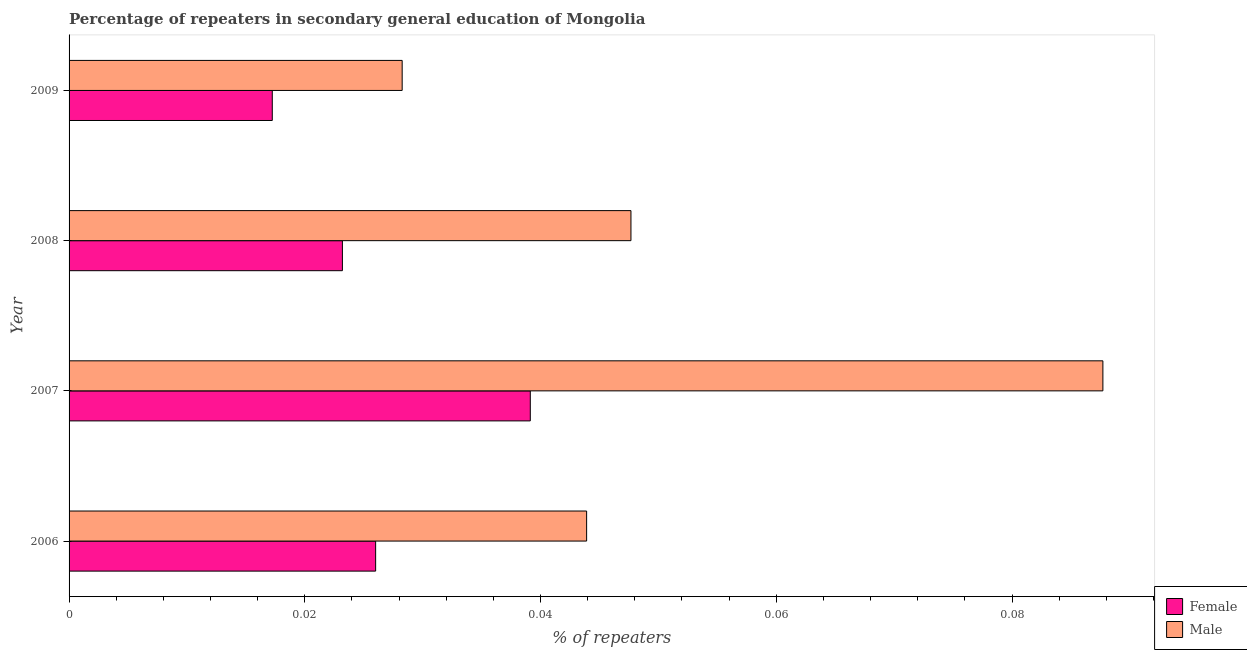How many different coloured bars are there?
Provide a short and direct response. 2. How many groups of bars are there?
Provide a succinct answer. 4. Are the number of bars per tick equal to the number of legend labels?
Offer a very short reply. Yes. Are the number of bars on each tick of the Y-axis equal?
Offer a terse response. Yes. In how many cases, is the number of bars for a given year not equal to the number of legend labels?
Offer a terse response. 0. What is the percentage of female repeaters in 2006?
Give a very brief answer. 0.03. Across all years, what is the maximum percentage of female repeaters?
Your response must be concise. 0.04. Across all years, what is the minimum percentage of female repeaters?
Offer a terse response. 0.02. In which year was the percentage of male repeaters minimum?
Your answer should be very brief. 2009. What is the total percentage of male repeaters in the graph?
Provide a short and direct response. 0.21. What is the difference between the percentage of male repeaters in 2006 and that in 2007?
Ensure brevity in your answer.  -0.04. What is the difference between the percentage of male repeaters in 2006 and the percentage of female repeaters in 2007?
Offer a terse response. 0. What is the average percentage of male repeaters per year?
Give a very brief answer. 0.05. In the year 2009, what is the difference between the percentage of female repeaters and percentage of male repeaters?
Make the answer very short. -0.01. In how many years, is the percentage of male repeaters greater than 0.048 %?
Make the answer very short. 1. What is the ratio of the percentage of female repeaters in 2007 to that in 2008?
Give a very brief answer. 1.69. Is the percentage of female repeaters in 2006 less than that in 2008?
Make the answer very short. No. What is the difference between the highest and the second highest percentage of female repeaters?
Make the answer very short. 0.01. What is the difference between the highest and the lowest percentage of female repeaters?
Provide a short and direct response. 0.02. In how many years, is the percentage of male repeaters greater than the average percentage of male repeaters taken over all years?
Ensure brevity in your answer.  1. What does the 2nd bar from the top in 2009 represents?
Provide a succinct answer. Female. How many bars are there?
Offer a very short reply. 8. Are all the bars in the graph horizontal?
Your answer should be compact. Yes. How many years are there in the graph?
Offer a very short reply. 4. How many legend labels are there?
Provide a short and direct response. 2. How are the legend labels stacked?
Provide a short and direct response. Vertical. What is the title of the graph?
Offer a terse response. Percentage of repeaters in secondary general education of Mongolia. What is the label or title of the X-axis?
Offer a terse response. % of repeaters. What is the label or title of the Y-axis?
Ensure brevity in your answer.  Year. What is the % of repeaters of Female in 2006?
Make the answer very short. 0.03. What is the % of repeaters in Male in 2006?
Your answer should be very brief. 0.04. What is the % of repeaters in Female in 2007?
Provide a short and direct response. 0.04. What is the % of repeaters of Male in 2007?
Make the answer very short. 0.09. What is the % of repeaters of Female in 2008?
Provide a succinct answer. 0.02. What is the % of repeaters in Male in 2008?
Offer a very short reply. 0.05. What is the % of repeaters of Female in 2009?
Provide a short and direct response. 0.02. What is the % of repeaters of Male in 2009?
Offer a terse response. 0.03. Across all years, what is the maximum % of repeaters in Female?
Keep it short and to the point. 0.04. Across all years, what is the maximum % of repeaters of Male?
Give a very brief answer. 0.09. Across all years, what is the minimum % of repeaters of Female?
Make the answer very short. 0.02. Across all years, what is the minimum % of repeaters in Male?
Keep it short and to the point. 0.03. What is the total % of repeaters in Female in the graph?
Offer a very short reply. 0.11. What is the total % of repeaters of Male in the graph?
Make the answer very short. 0.21. What is the difference between the % of repeaters of Female in 2006 and that in 2007?
Offer a terse response. -0.01. What is the difference between the % of repeaters in Male in 2006 and that in 2007?
Give a very brief answer. -0.04. What is the difference between the % of repeaters of Female in 2006 and that in 2008?
Offer a terse response. 0. What is the difference between the % of repeaters in Male in 2006 and that in 2008?
Provide a short and direct response. -0. What is the difference between the % of repeaters of Female in 2006 and that in 2009?
Your answer should be compact. 0.01. What is the difference between the % of repeaters of Male in 2006 and that in 2009?
Your answer should be compact. 0.02. What is the difference between the % of repeaters of Female in 2007 and that in 2008?
Offer a terse response. 0.02. What is the difference between the % of repeaters of Female in 2007 and that in 2009?
Ensure brevity in your answer.  0.02. What is the difference between the % of repeaters in Male in 2007 and that in 2009?
Provide a succinct answer. 0.06. What is the difference between the % of repeaters of Female in 2008 and that in 2009?
Your answer should be very brief. 0.01. What is the difference between the % of repeaters of Male in 2008 and that in 2009?
Offer a very short reply. 0.02. What is the difference between the % of repeaters in Female in 2006 and the % of repeaters in Male in 2007?
Ensure brevity in your answer.  -0.06. What is the difference between the % of repeaters in Female in 2006 and the % of repeaters in Male in 2008?
Keep it short and to the point. -0.02. What is the difference between the % of repeaters in Female in 2006 and the % of repeaters in Male in 2009?
Provide a succinct answer. -0. What is the difference between the % of repeaters of Female in 2007 and the % of repeaters of Male in 2008?
Offer a terse response. -0.01. What is the difference between the % of repeaters in Female in 2007 and the % of repeaters in Male in 2009?
Your answer should be very brief. 0.01. What is the difference between the % of repeaters of Female in 2008 and the % of repeaters of Male in 2009?
Provide a short and direct response. -0.01. What is the average % of repeaters of Female per year?
Your answer should be compact. 0.03. What is the average % of repeaters in Male per year?
Ensure brevity in your answer.  0.05. In the year 2006, what is the difference between the % of repeaters of Female and % of repeaters of Male?
Provide a succinct answer. -0.02. In the year 2007, what is the difference between the % of repeaters in Female and % of repeaters in Male?
Offer a very short reply. -0.05. In the year 2008, what is the difference between the % of repeaters of Female and % of repeaters of Male?
Ensure brevity in your answer.  -0.02. In the year 2009, what is the difference between the % of repeaters in Female and % of repeaters in Male?
Offer a terse response. -0.01. What is the ratio of the % of repeaters of Female in 2006 to that in 2007?
Your response must be concise. 0.66. What is the ratio of the % of repeaters in Male in 2006 to that in 2007?
Keep it short and to the point. 0.5. What is the ratio of the % of repeaters of Female in 2006 to that in 2008?
Provide a short and direct response. 1.12. What is the ratio of the % of repeaters of Male in 2006 to that in 2008?
Give a very brief answer. 0.92. What is the ratio of the % of repeaters of Female in 2006 to that in 2009?
Offer a terse response. 1.51. What is the ratio of the % of repeaters in Male in 2006 to that in 2009?
Ensure brevity in your answer.  1.55. What is the ratio of the % of repeaters in Female in 2007 to that in 2008?
Provide a succinct answer. 1.69. What is the ratio of the % of repeaters in Male in 2007 to that in 2008?
Keep it short and to the point. 1.84. What is the ratio of the % of repeaters of Female in 2007 to that in 2009?
Your response must be concise. 2.27. What is the ratio of the % of repeaters of Male in 2007 to that in 2009?
Ensure brevity in your answer.  3.1. What is the ratio of the % of repeaters in Female in 2008 to that in 2009?
Offer a very short reply. 1.35. What is the ratio of the % of repeaters in Male in 2008 to that in 2009?
Provide a succinct answer. 1.69. What is the difference between the highest and the second highest % of repeaters in Female?
Your answer should be compact. 0.01. What is the difference between the highest and the lowest % of repeaters of Female?
Provide a succinct answer. 0.02. What is the difference between the highest and the lowest % of repeaters in Male?
Provide a succinct answer. 0.06. 